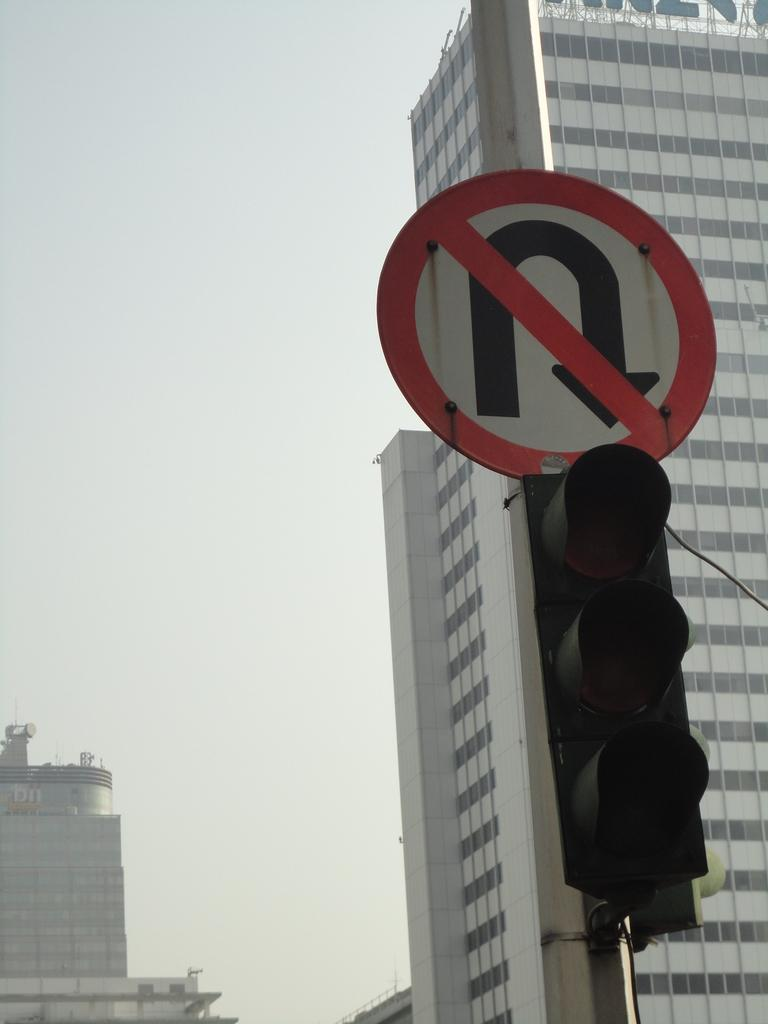What is located on the right side of the image? There is a traffic signal and a sign board on a pole on the right side of the image. What can be seen in the background of the image? There are buildings, glass doors, a name board, poles, and the sky visible in the background of the image. What type of cake is being served at the organization in the image? There is no organization or cake present in the image. How does the person in the image manage their cough? There is no person or cough present in the image. 